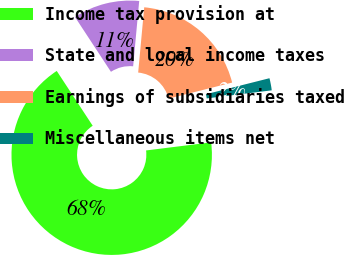Convert chart to OTSL. <chart><loc_0><loc_0><loc_500><loc_500><pie_chart><fcel>Income tax provision at<fcel>State and local income taxes<fcel>Earnings of subsidiaries taxed<fcel>Miscellaneous items net<nl><fcel>67.73%<fcel>10.71%<fcel>19.6%<fcel>1.96%<nl></chart> 